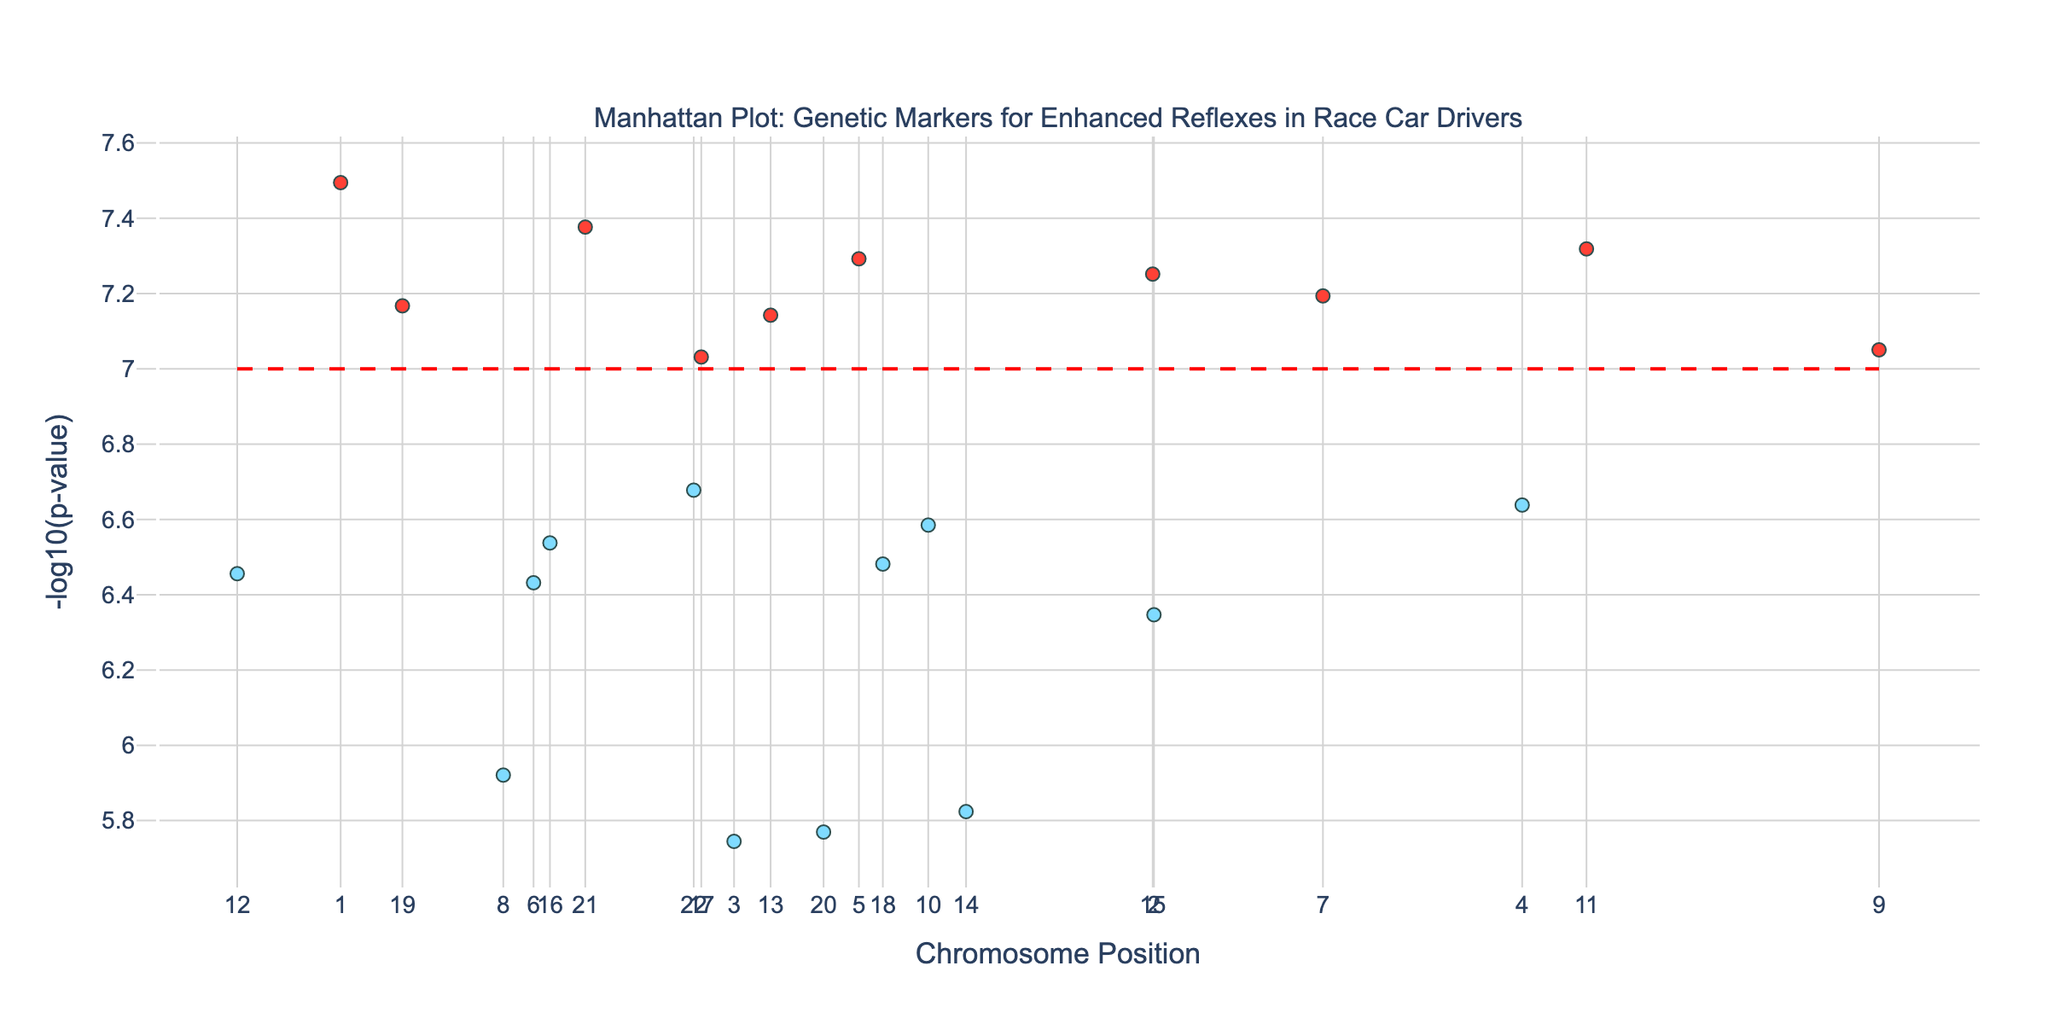What's the title of the plot? The title of the plot is displayed at the top of the figure. It reads "Manhattan Plot: Genetic Markers for Enhanced Reflexes in Race Car Drivers".
Answer: Manhattan Plot: Genetic Markers for Enhanced Reflexes in Race Car Drivers What does the y-axis represent? The y-axis represents the -log10(p-value) of the genetic markers. This transformation highlights the significance of each genetic marker, with higher values indicating more significant markers.
Answer: -log10(p-value) How many data points are highlighted with a different color? Data points with -log10(p-value) greater than 7 are highlighted in red, while others are in light blue. There are 5 points in red.
Answer: 5 Which gene shows the most significant association with enhanced reflexes and decision-making skills? By looking for the highest -log10(p-value) value on the y-axis, we can identify the most significant gene. The highest point corresponds to the gene ADCY9 on Chromosome 1 with a -log10(p-value) of 7.49.
Answer: ADCY9 What is the significance threshold used in the plot? The significance threshold line, which is dashed and red, is at y = 7, representing a -log10(p-value) of 7. Any marker above this threshold is considered significantly associated.
Answer: 7 Which chromosome has the highest number of significant markers above the threshold line? Chromosome 9 has multiple markers close to significant levels but only one surpasses the significance line - DBH. By observing the plot,  Chromosome 9 has the highest prominence in the top results.
Answer: Chromosome 9 What is the genetic marker with the second highest significance, and which chromosome is it on? After ADCY9, the next highest peak represents the gene CDK6 on Chromosome 7 with a -log10(p-value) close to 7.19.
Answer: CDK6 on Chromosome 7 How does the significance of the gene ITGA1 compare to that of ANK3? Both genetic markers ITGA1 (Chromosome 5) and ANK3 (Chromosome 10) are above the threshold line, but ITGA1 has a higher -log10(p-value) compared to ANK3.
Answer: ITGA1 is more significant than ANK3 Is the gene SLC6A1 significant according to the plot? SLC6A1 located on Chromosome 3 has a -log10(p-value) below the threshold line, so it’s not considered significant.
Answer: No How are the colors used in the plot? Colors are used to differentiate significance. Points above the significance threshold (7) are colored red whereas those below are light blue. Red points highlight significantly associated genetic markers.
Answer: Red and Light Blue 